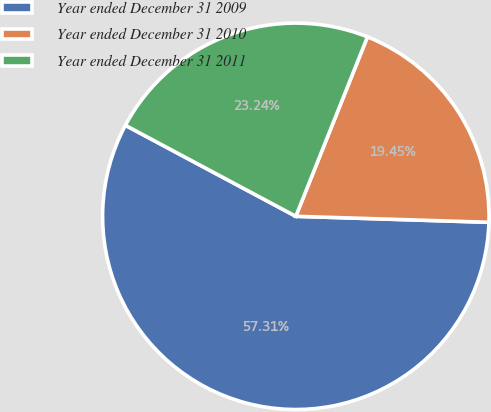<chart> <loc_0><loc_0><loc_500><loc_500><pie_chart><fcel>Year ended December 31 2009<fcel>Year ended December 31 2010<fcel>Year ended December 31 2011<nl><fcel>57.31%<fcel>19.45%<fcel>23.24%<nl></chart> 